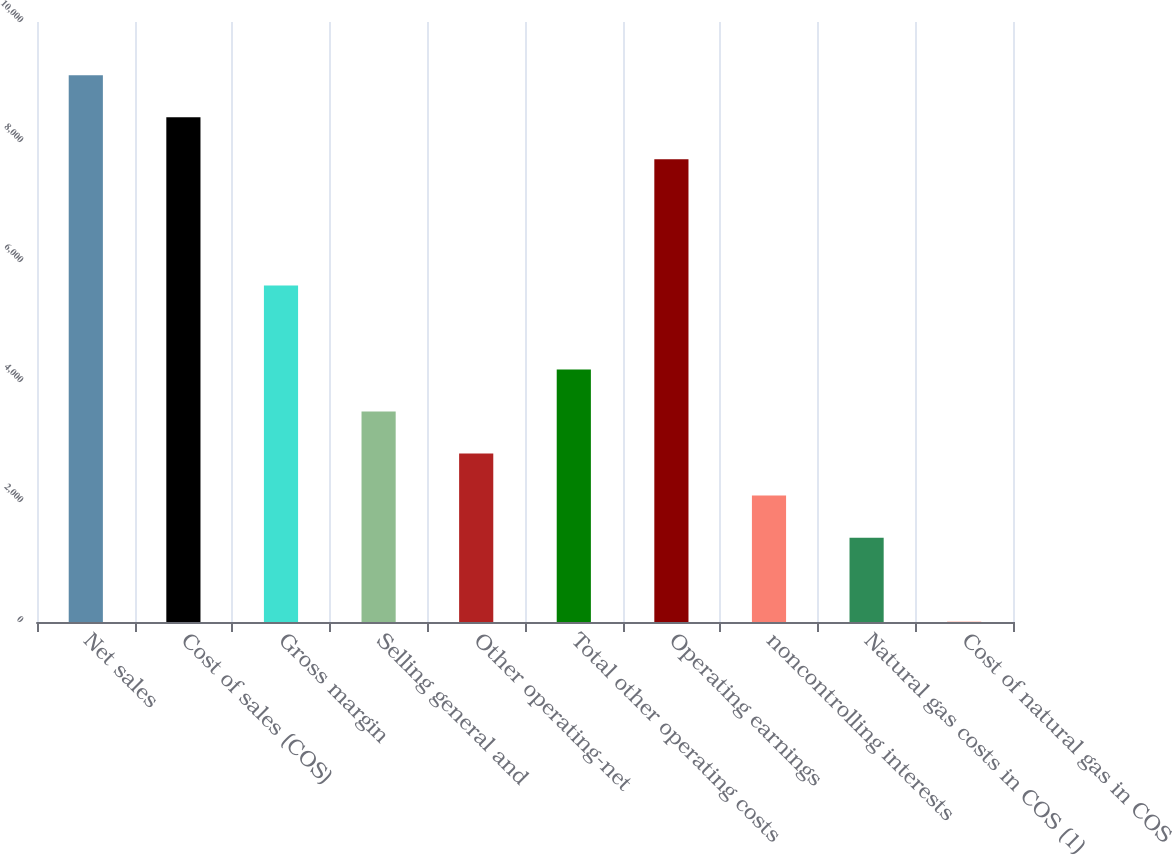<chart> <loc_0><loc_0><loc_500><loc_500><bar_chart><fcel>Net sales<fcel>Cost of sales (COS)<fcel>Gross margin<fcel>Selling general and<fcel>Other operating-net<fcel>Total other operating costs<fcel>Operating earnings<fcel>noncontrolling interests<fcel>Natural gas costs in COS (1)<fcel>Cost of natural gas in COS<nl><fcel>9113.06<fcel>8412.38<fcel>5609.66<fcel>3507.62<fcel>2806.94<fcel>4208.3<fcel>7711.7<fcel>2106.26<fcel>1405.58<fcel>4.22<nl></chart> 